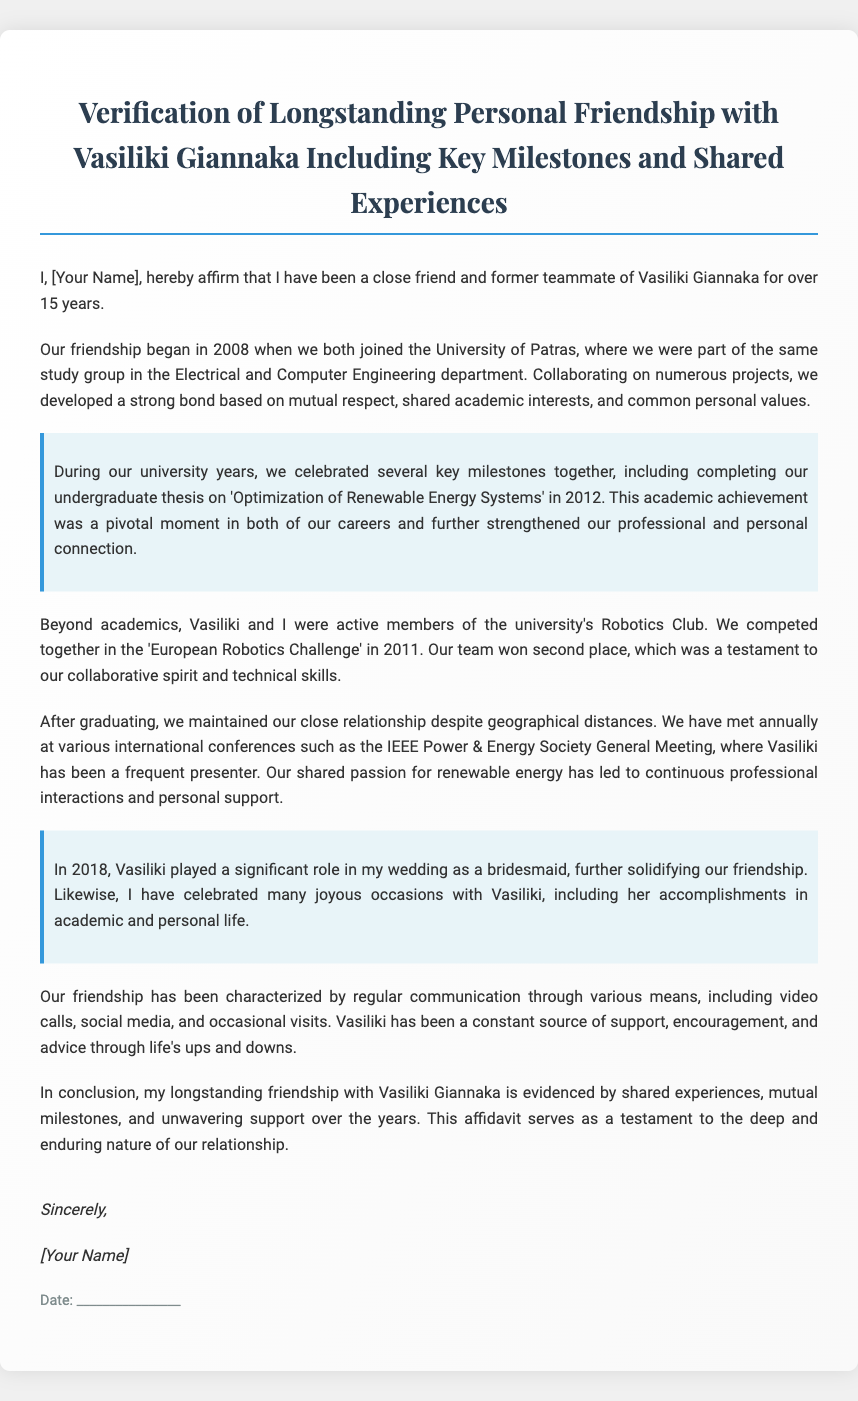What year did their friendship begin? The document states that their friendship began in 2008.
Answer: 2008 What was the topic of their undergraduate thesis? The document mentions that the thesis was on 'Optimization of Renewable Energy Systems'.
Answer: Optimization of Renewable Energy Systems In what year did they compete in the European Robotics Challenge? According to the document, they competed in 2011.
Answer: 2011 What significant role did Vasiliki play in the author's life in 2018? The document notes that Vasiliki was a bridesmaid at the author's wedding in 2018.
Answer: Bridesmaid How many years have they been friends? The document indicates that they have been friends for over 15 years.
Answer: Over 15 years What event solidified their friendship during their university years? The completion of their undergraduate thesis is highlighted as a pivotal moment in their friendship.
Answer: Completion of their undergraduate thesis At which international conference do they meet annually? The document states they meet at the IEEE Power & Energy Society General Meeting.
Answer: IEEE Power & Energy Society General Meeting What type of support has Vasiliki consistently provided? The document describes Vasiliki as a source of support, encouragement, and advice.
Answer: Support, encouragement, and advice 